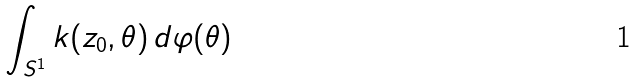Convert formula to latex. <formula><loc_0><loc_0><loc_500><loc_500>\int _ { S ^ { 1 } } k ( z _ { 0 } , \theta ) \, d \varphi ( \theta )</formula> 